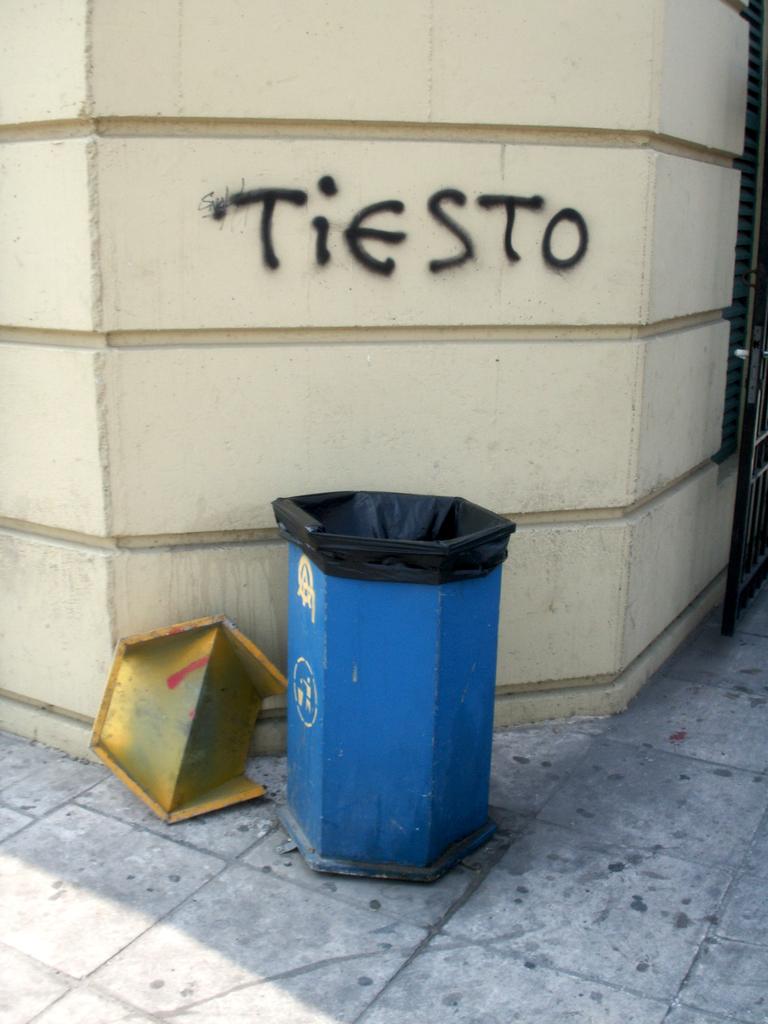What's spray painted on the wall?
Your answer should be very brief. Tiesto. 